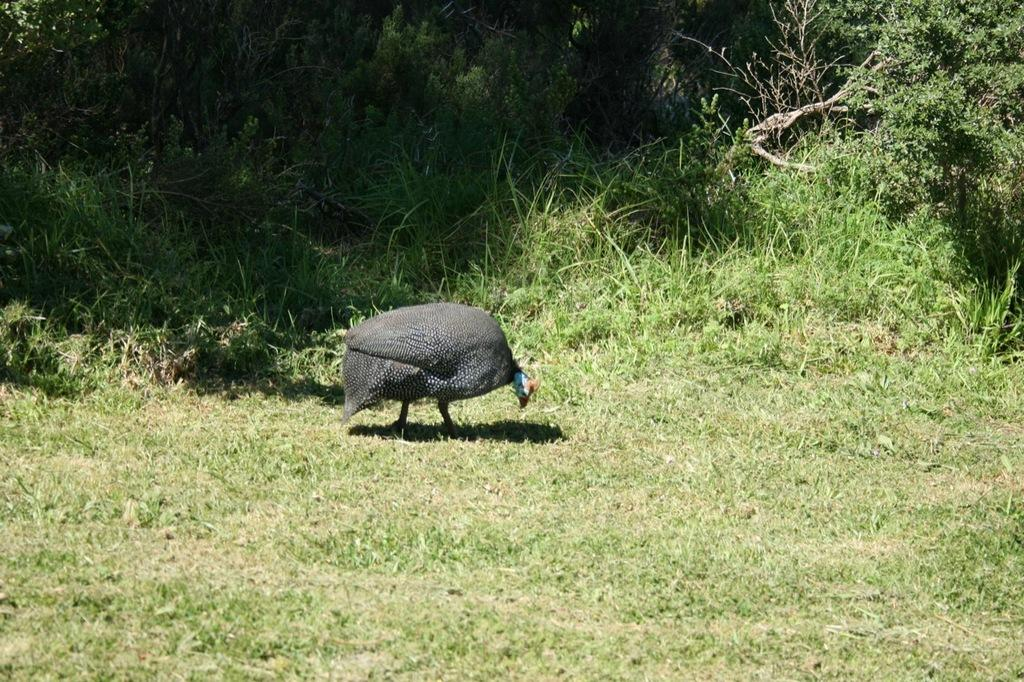What animal can be seen in the image? There is a bird standing in the image. What type of environment is visible in the background of the image? There are trees visible in the background of the image. What type of vegetation is visible at the bottom of the image? There is grass visible at the bottom of the image. Where is the bird's nest located in the image? There is no nest visible in the image; only the bird standing on the grass is present. 